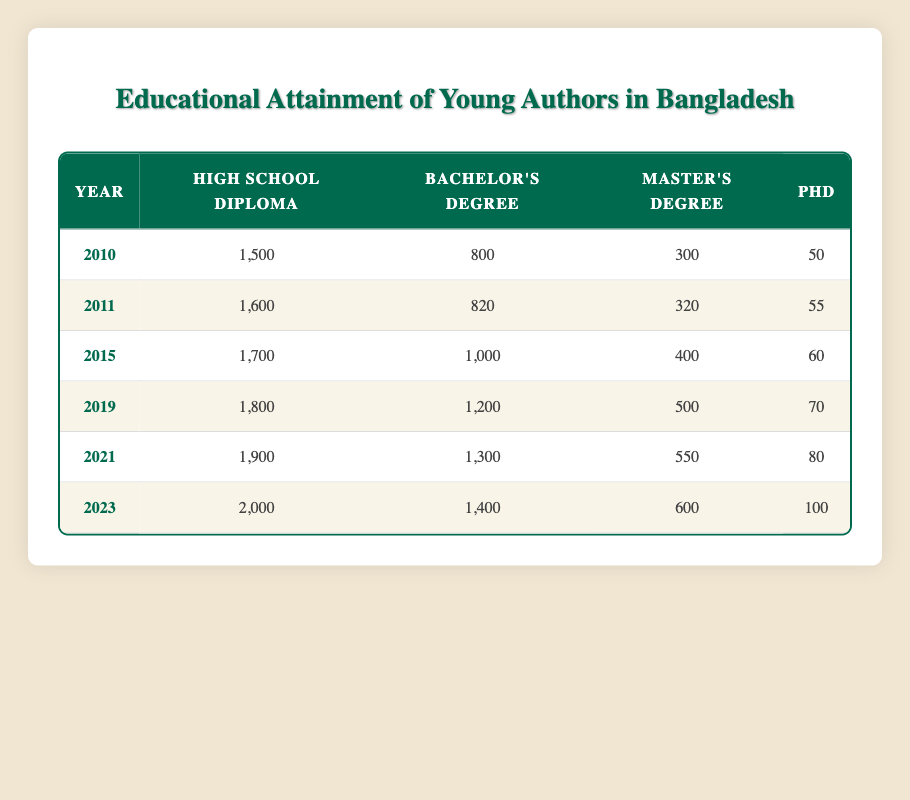What was the total number of authors with a high school diploma in 2023? In the year 2023, the table shows that there were 2,000 authors with a high school diploma.
Answer: 2,000 What is the percentage increase in authors with a bachelor's degree from 2010 to 2023? In 2010, there were 800 authors with a bachelor's degree, and in 2023, there were 1,400 authors. The increase is (1,400 - 800) = 600. The percentage increase is (600/800) * 100 = 75%.
Answer: 75% Did the number of authors with a PhD ever decrease during the years shown in the table? By examining each year, the numbers are 50 in 2010, 55 in 2011, 60 in 2015, 70 in 2019, 80 in 2021, and 100 in 2023. All numbers show an increase, meaning there was never a decrease.
Answer: No How many more authors with a master's degree were there in 2021 compared to 2015? In 2021, there were 550 authors with a master's degree, and in 2015, there were 400. The difference is 550 - 400 = 150 more authors in 2021 than in 2015.
Answer: 150 What was the average number of authors with a PhD over all the years listed? The PhD numbers for each year are 50, 55, 60, 70, 80, and 100. Adding these gives 50 + 55 + 60 + 70 + 80 + 100 = 415. There are 6 years, so the average is 415 / 6 ≈ 69.17. Rounding gives approximately 69.
Answer: Approximately 69 